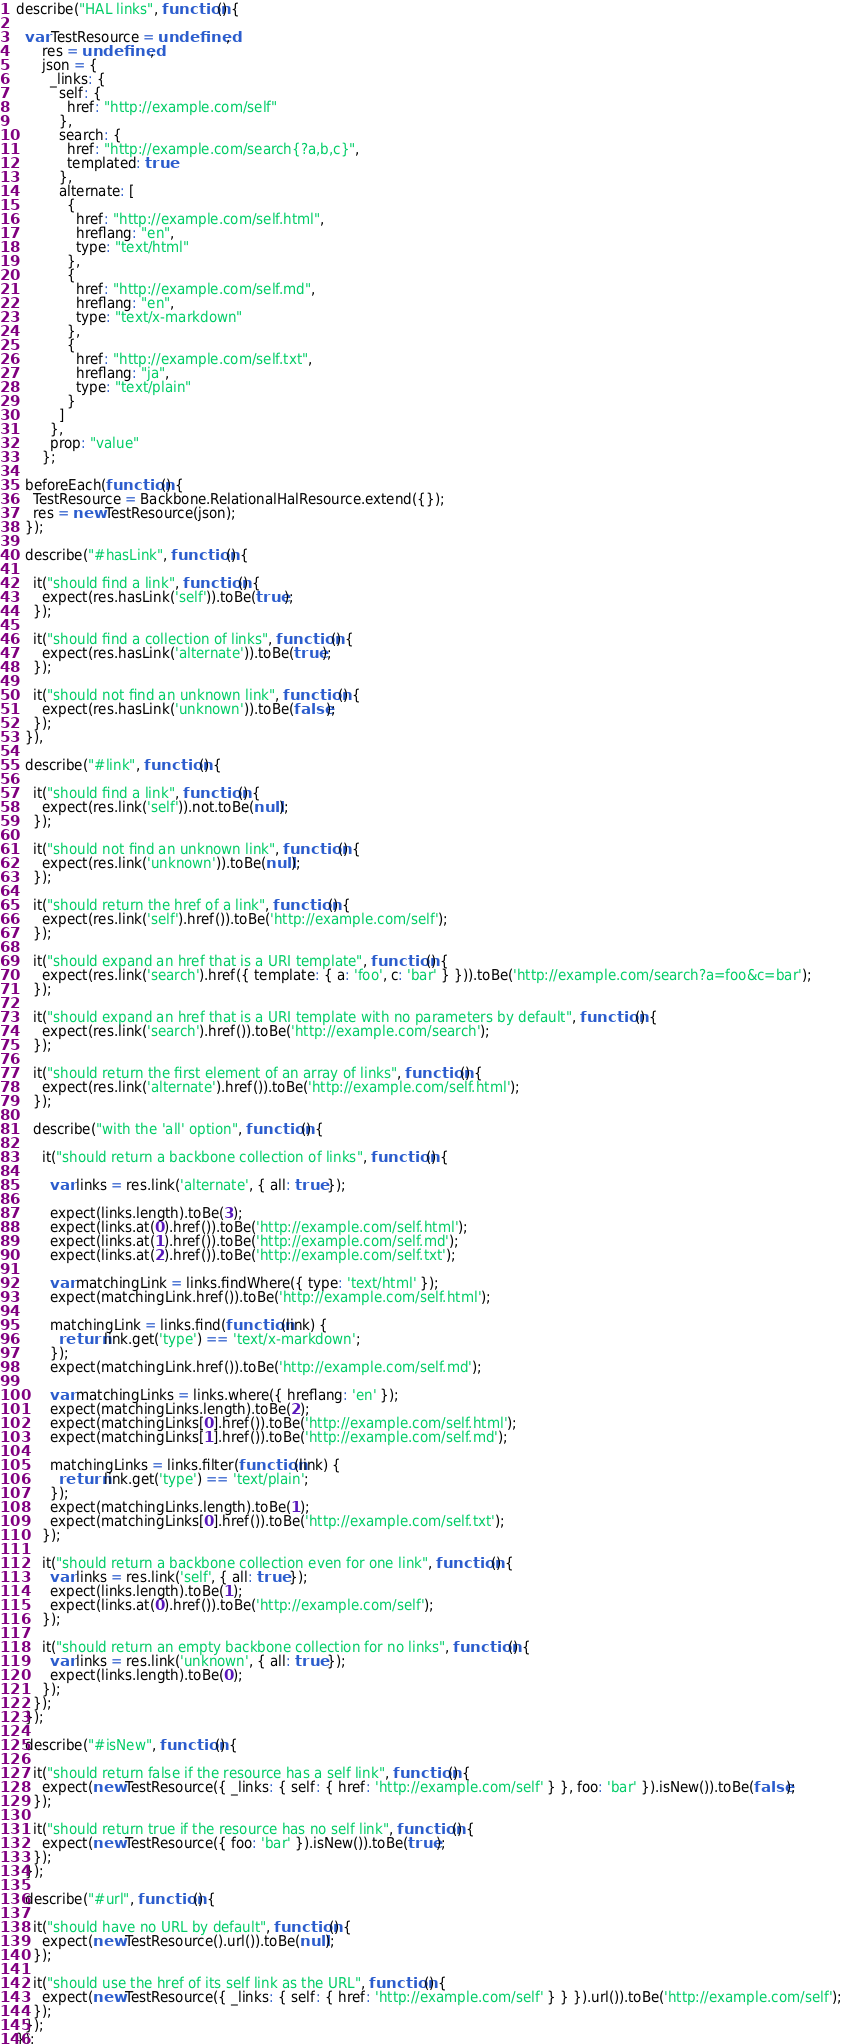Convert code to text. <code><loc_0><loc_0><loc_500><loc_500><_JavaScript_>describe("HAL links", function() {

  var TestResource = undefined,
      res = undefined,
      json = {
        _links: {
          self: {
            href: "http://example.com/self"
          },
          search: {
            href: "http://example.com/search{?a,b,c}",
            templated: true
          },
          alternate: [
            {
              href: "http://example.com/self.html",
              hreflang: "en",
              type: "text/html"
            },
            {
              href: "http://example.com/self.md",
              hreflang: "en",
              type: "text/x-markdown"
            },
            {
              href: "http://example.com/self.txt",
              hreflang: "ja",
              type: "text/plain"
            }
          ]
        },
        prop: "value"
      };

  beforeEach(function() {
    TestResource = Backbone.RelationalHalResource.extend({});
    res = new TestResource(json);
  });

  describe("#hasLink", function() {

    it("should find a link", function() {
      expect(res.hasLink('self')).toBe(true);
    });

    it("should find a collection of links", function() {
      expect(res.hasLink('alternate')).toBe(true);
    });

    it("should not find an unknown link", function() {
      expect(res.hasLink('unknown')).toBe(false);
    });
  }),

  describe("#link", function() {

    it("should find a link", function() {
      expect(res.link('self')).not.toBe(null);
    });

    it("should not find an unknown link", function() {
      expect(res.link('unknown')).toBe(null);
    });

    it("should return the href of a link", function() {
      expect(res.link('self').href()).toBe('http://example.com/self');
    });

    it("should expand an href that is a URI template", function() {
      expect(res.link('search').href({ template: { a: 'foo', c: 'bar' } })).toBe('http://example.com/search?a=foo&c=bar');
    });

    it("should expand an href that is a URI template with no parameters by default", function() {
      expect(res.link('search').href()).toBe('http://example.com/search');
    });

    it("should return the first element of an array of links", function() {
      expect(res.link('alternate').href()).toBe('http://example.com/self.html');
    });

    describe("with the 'all' option", function() {

      it("should return a backbone collection of links", function() {

        var links = res.link('alternate', { all: true });

        expect(links.length).toBe(3);
        expect(links.at(0).href()).toBe('http://example.com/self.html');
        expect(links.at(1).href()).toBe('http://example.com/self.md');
        expect(links.at(2).href()).toBe('http://example.com/self.txt');
        
        var matchingLink = links.findWhere({ type: 'text/html' });
        expect(matchingLink.href()).toBe('http://example.com/self.html');

        matchingLink = links.find(function(link) {
          return link.get('type') == 'text/x-markdown';
        });
        expect(matchingLink.href()).toBe('http://example.com/self.md');

        var matchingLinks = links.where({ hreflang: 'en' });
        expect(matchingLinks.length).toBe(2);
        expect(matchingLinks[0].href()).toBe('http://example.com/self.html');
        expect(matchingLinks[1].href()).toBe('http://example.com/self.md');

        matchingLinks = links.filter(function(link) {
          return link.get('type') == 'text/plain';
        });
        expect(matchingLinks.length).toBe(1);
        expect(matchingLinks[0].href()).toBe('http://example.com/self.txt');
      });

      it("should return a backbone collection even for one link", function() {
        var links = res.link('self', { all: true });
        expect(links.length).toBe(1);
        expect(links.at(0).href()).toBe('http://example.com/self');
      });

      it("should return an empty backbone collection for no links", function() {
        var links = res.link('unknown', { all: true });
        expect(links.length).toBe(0);
      });
    });
  });

  describe("#isNew", function() {

    it("should return false if the resource has a self link", function() {
      expect(new TestResource({ _links: { self: { href: 'http://example.com/self' } }, foo: 'bar' }).isNew()).toBe(false);
    });

    it("should return true if the resource has no self link", function() {
      expect(new TestResource({ foo: 'bar' }).isNew()).toBe(true);
    });
  });

  describe("#url", function() {

    it("should have no URL by default", function() {
      expect(new TestResource().url()).toBe(null);
    });

    it("should use the href of its self link as the URL", function() {
      expect(new TestResource({ _links: { self: { href: 'http://example.com/self' } } }).url()).toBe('http://example.com/self');
    });
  });
});
</code> 